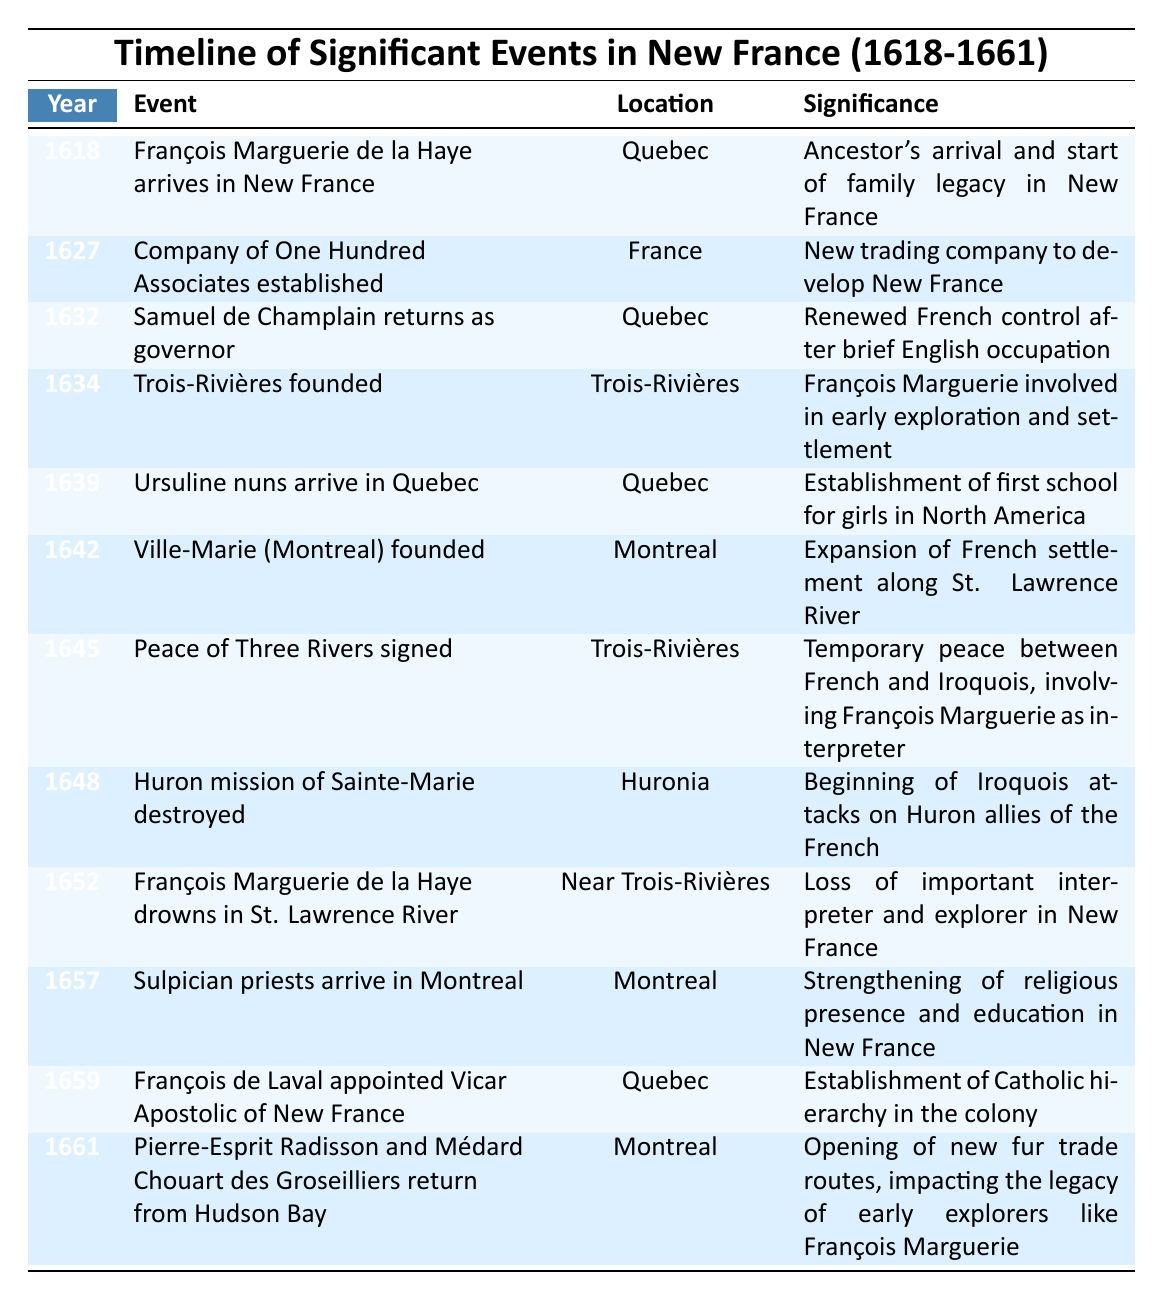What year did François Marguerie de la Haye arrive in New France? The table shows that François Marguerie de la Haye arrived in New France in the year 1618.
Answer: 1618 What event occurred in 1645? According to the table, in 1645, the "Peace of Three Rivers" was signed.
Answer: Peace of Three Rivers signed Which location is associated with the founding of Ville-Marie? The table indicates that Ville-Marie, now known as Montreal, was founded in the location of Montreal.
Answer: Montreal How many significant events are listed for the year 1652? The table lists only one significant event for the year 1652, which is the drowning of François Marguerie de la Haye.
Answer: 1 Who was involved in the temporary peace signed in 1645? The table mentions that François Marguerie was involved as an interpreter in the temporary peace between the French and Iroquois in 1645.
Answer: François Marguerie Was there an event related to education in 1639? Yes, the table states that the Ursuline nuns arrived in Quebec in 1639, which was significant for establishing the first school for girls in North America.
Answer: Yes What was the significance of the year 1659? The year 1659 is significant as it marks the appointment of François de Laval as Vicar Apostolic of New France, establishing the Catholic hierarchy in the colony.
Answer: Establishment of Catholic hierarchy In which year did the Huron mission get destroyed? The table indicates that the Huron mission of Sainte-Marie was destroyed in 1648.
Answer: 1648 What is the difference in years between the arrival of François Marguerie de la Haye and the establishment of the Company of One Hundred Associates? François Marguerie de la Haye arrived in 1618 and the Company of One Hundred Associates was established in 1627. The difference is 1627 - 1618 = 9 years.
Answer: 9 years Did the foundation of Trois-Rivières involve François Marguerie? Yes, the table states that François Marguerie was involved in the founding of Trois-Rivières in 1634.
Answer: Yes What was the last significant event listed in the table? The last significant event listed in the table is the return of Pierre-Esprit Radisson and Médard Chouart des Groseilliers from Hudson Bay in 1661.
Answer: Return from Hudson Bay in 1661 